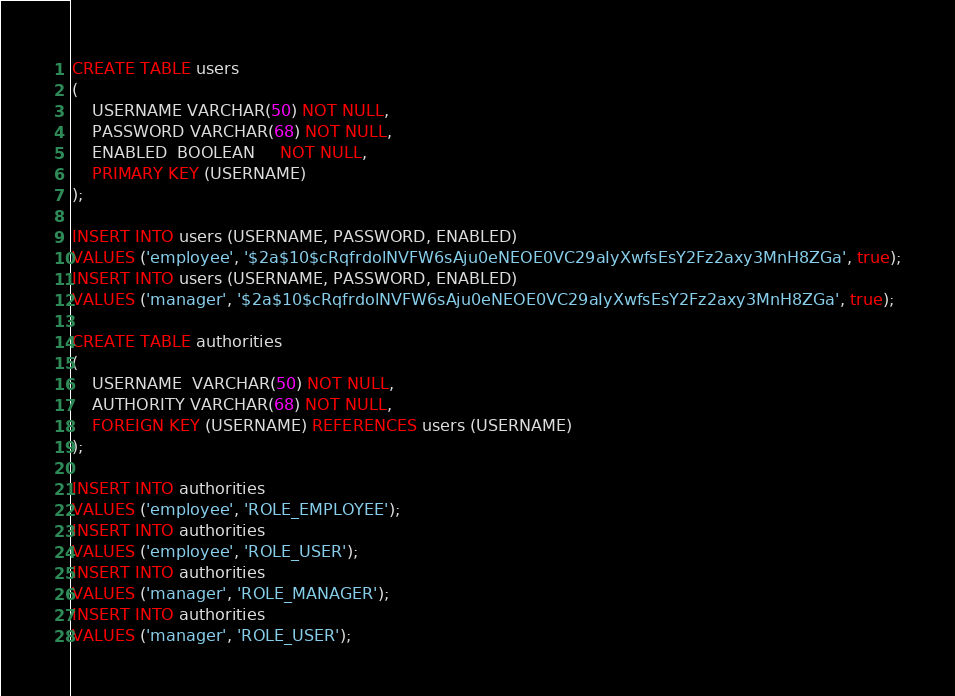<code> <loc_0><loc_0><loc_500><loc_500><_SQL_>CREATE TABLE users
(
    USERNAME VARCHAR(50) NOT NULL,
    PASSWORD VARCHAR(68) NOT NULL,
    ENABLED  BOOLEAN     NOT NULL,
    PRIMARY KEY (USERNAME)
);

INSERT INTO users (USERNAME, PASSWORD, ENABLED)
VALUES ('employee', '$2a$10$cRqfrdolNVFW6sAju0eNEOE0VC29aIyXwfsEsY2Fz2axy3MnH8ZGa', true);
INSERT INTO users (USERNAME, PASSWORD, ENABLED)
VALUES ('manager', '$2a$10$cRqfrdolNVFW6sAju0eNEOE0VC29aIyXwfsEsY2Fz2axy3MnH8ZGa', true);

CREATE TABLE authorities
(
    USERNAME  VARCHAR(50) NOT NULL,
    AUTHORITY VARCHAR(68) NOT NULL,
    FOREIGN KEY (USERNAME) REFERENCES users (USERNAME)
);

INSERT INTO authorities
VALUES ('employee', 'ROLE_EMPLOYEE');
INSERT INTO authorities
VALUES ('employee', 'ROLE_USER');
INSERT INTO authorities
VALUES ('manager', 'ROLE_MANAGER');
INSERT INTO authorities
VALUES ('manager', 'ROLE_USER');</code> 